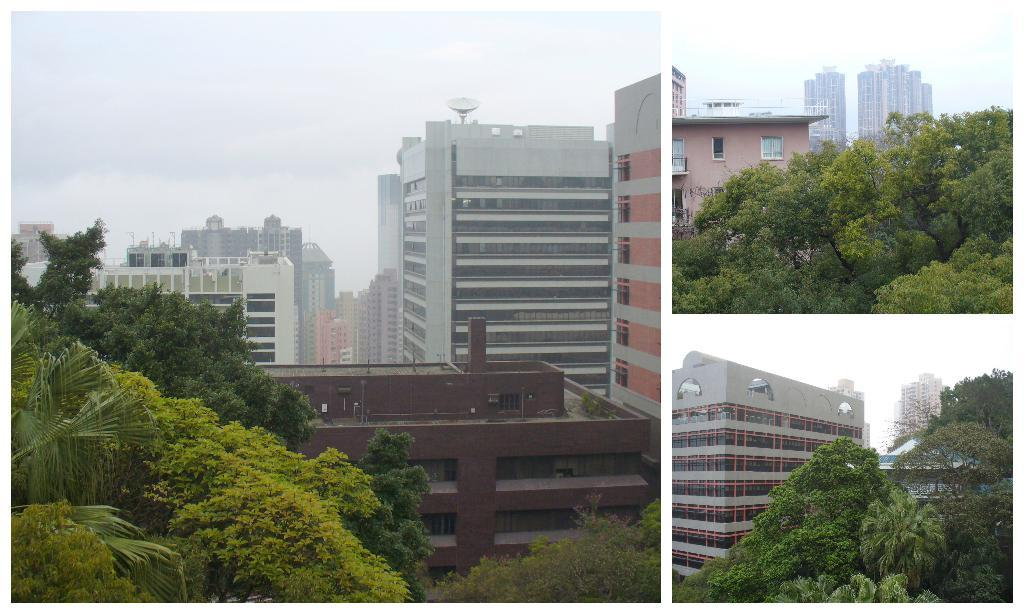How many images are included in the collage? The collage contains three images. What can be seen in each of the images? Each image contains buildings and trees. What is the condition of the sky in the collage? The sky in the collage is covered with clouds. Can you see a hen in any of the images? There is no hen present in any of the images; they contain buildings and trees. 